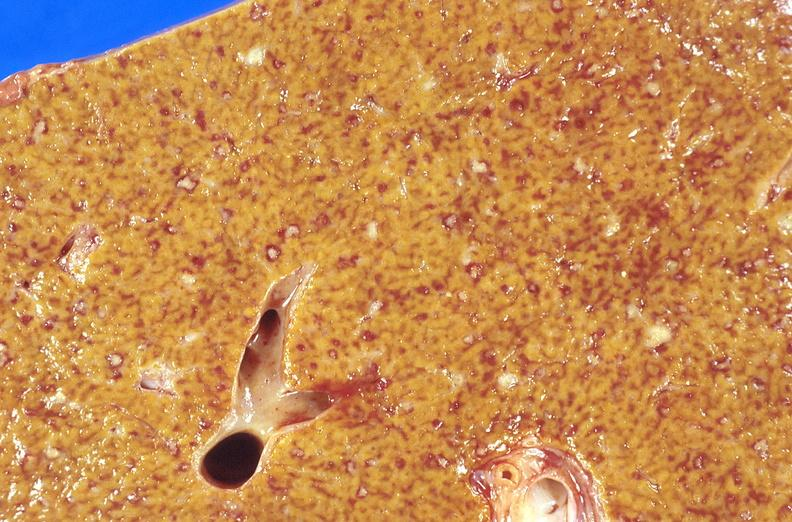s slide present?
Answer the question using a single word or phrase. No 